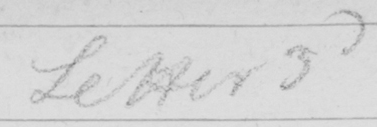Can you read and transcribe this handwriting? Letter 3d 